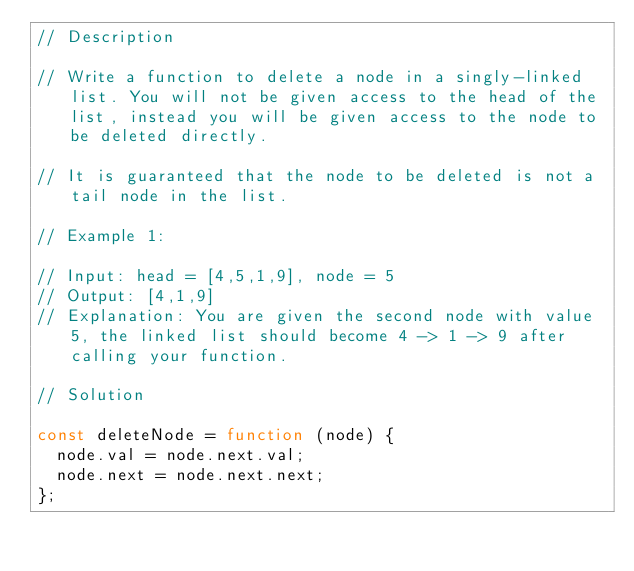<code> <loc_0><loc_0><loc_500><loc_500><_JavaScript_>// Description

// Write a function to delete a node in a singly-linked list. You will not be given access to the head of the list, instead you will be given access to the node to be deleted directly.

// It is guaranteed that the node to be deleted is not a tail node in the list.

// Example 1:

// Input: head = [4,5,1,9], node = 5
// Output: [4,1,9]
// Explanation: You are given the second node with value 5, the linked list should become 4 -> 1 -> 9 after calling your function.

// Solution

const deleteNode = function (node) {
  node.val = node.next.val;
  node.next = node.next.next;
};
</code> 